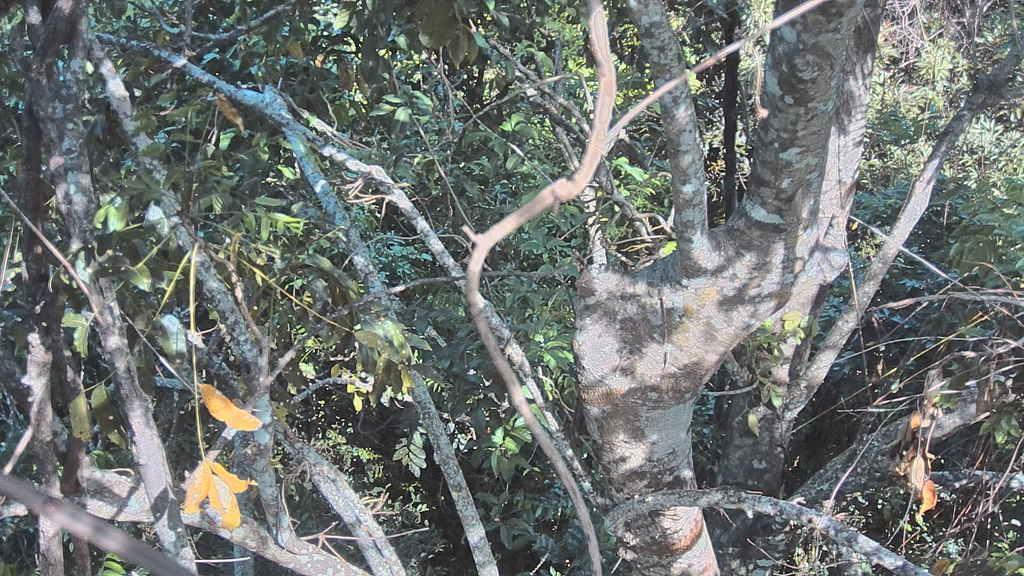Describe this image in one or two sentences. Here I can see few trees and plants along with the leaves and stems. 